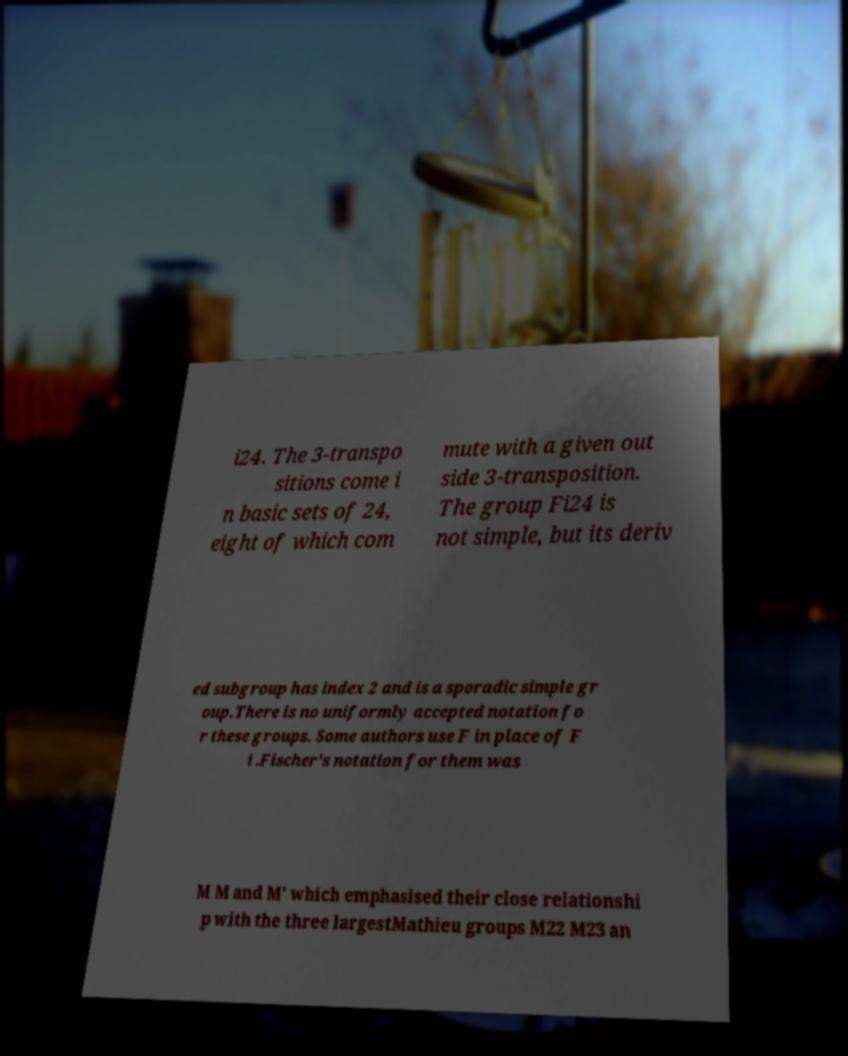What messages or text are displayed in this image? I need them in a readable, typed format. i24. The 3-transpo sitions come i n basic sets of 24, eight of which com mute with a given out side 3-transposition. The group Fi24 is not simple, but its deriv ed subgroup has index 2 and is a sporadic simple gr oup.There is no uniformly accepted notation fo r these groups. Some authors use F in place of F i .Fischer's notation for them was M M and M′ which emphasised their close relationshi p with the three largestMathieu groups M22 M23 an 